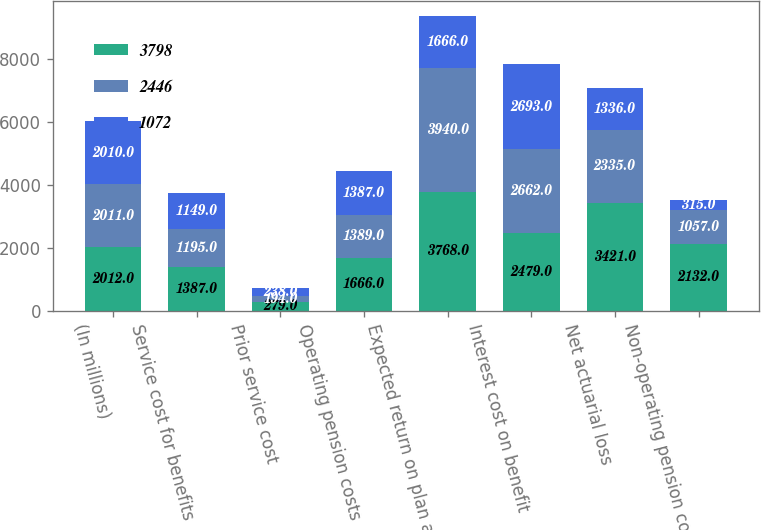<chart> <loc_0><loc_0><loc_500><loc_500><stacked_bar_chart><ecel><fcel>(In millions)<fcel>Service cost for benefits<fcel>Prior service cost<fcel>Operating pension costs<fcel>Expected return on plan assets<fcel>Interest cost on benefit<fcel>Net actuarial loss<fcel>Non-operating pension costs<nl><fcel>3798<fcel>2012<fcel>1387<fcel>279<fcel>1666<fcel>3768<fcel>2479<fcel>3421<fcel>2132<nl><fcel>2446<fcel>2011<fcel>1195<fcel>194<fcel>1389<fcel>3940<fcel>2662<fcel>2335<fcel>1057<nl><fcel>1072<fcel>2010<fcel>1149<fcel>238<fcel>1387<fcel>1666<fcel>2693<fcel>1336<fcel>315<nl></chart> 